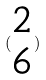<formula> <loc_0><loc_0><loc_500><loc_500>( \begin{matrix} 2 \\ 6 \end{matrix} )</formula> 